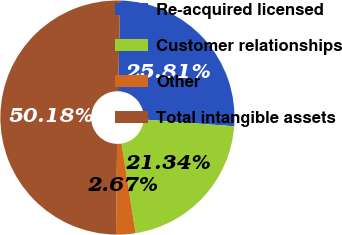<chart> <loc_0><loc_0><loc_500><loc_500><pie_chart><fcel>Re-acquired licensed<fcel>Customer relationships<fcel>Other<fcel>Total intangible assets<nl><fcel>25.81%<fcel>21.34%<fcel>2.67%<fcel>50.18%<nl></chart> 